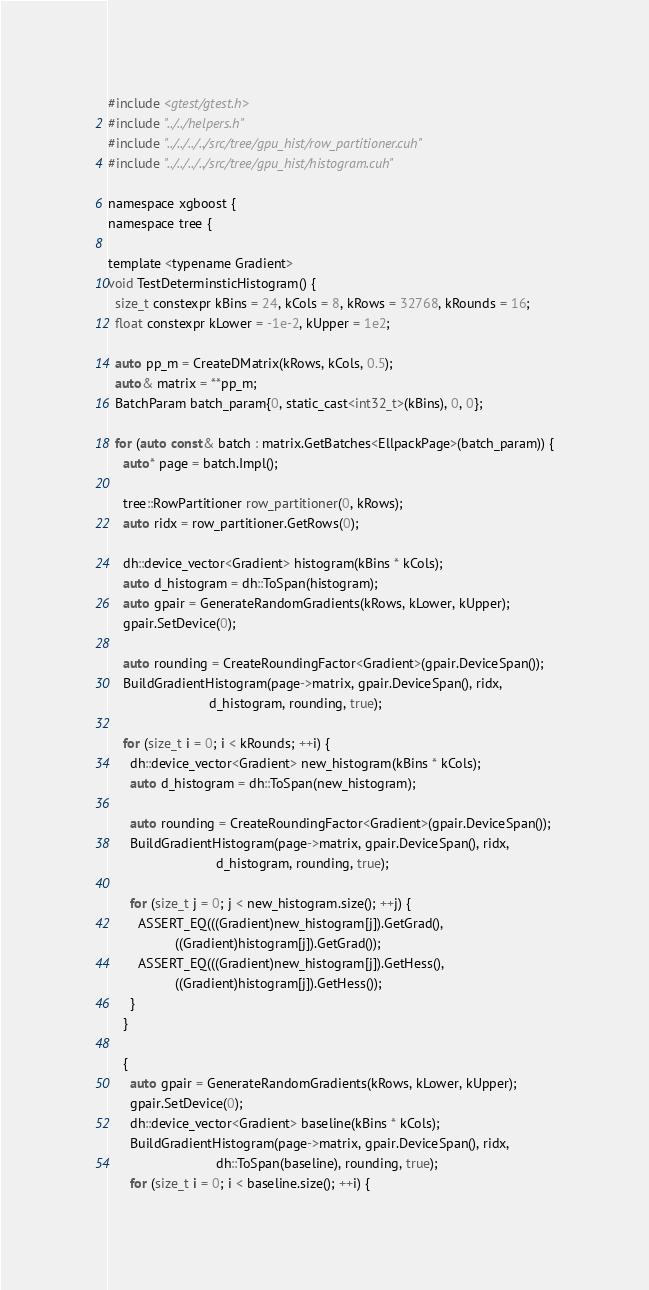Convert code to text. <code><loc_0><loc_0><loc_500><loc_500><_Cuda_>#include <gtest/gtest.h>
#include "../../helpers.h"
#include "../../../../src/tree/gpu_hist/row_partitioner.cuh"
#include "../../../../src/tree/gpu_hist/histogram.cuh"

namespace xgboost {
namespace tree {

template <typename Gradient>
void TestDeterminsticHistogram() {
  size_t constexpr kBins = 24, kCols = 8, kRows = 32768, kRounds = 16;
  float constexpr kLower = -1e-2, kUpper = 1e2;

  auto pp_m = CreateDMatrix(kRows, kCols, 0.5);
  auto& matrix = **pp_m;
  BatchParam batch_param{0, static_cast<int32_t>(kBins), 0, 0};

  for (auto const& batch : matrix.GetBatches<EllpackPage>(batch_param)) {
    auto* page = batch.Impl();

    tree::RowPartitioner row_partitioner(0, kRows);
    auto ridx = row_partitioner.GetRows(0);

    dh::device_vector<Gradient> histogram(kBins * kCols);
    auto d_histogram = dh::ToSpan(histogram);
    auto gpair = GenerateRandomGradients(kRows, kLower, kUpper);
    gpair.SetDevice(0);

    auto rounding = CreateRoundingFactor<Gradient>(gpair.DeviceSpan());
    BuildGradientHistogram(page->matrix, gpair.DeviceSpan(), ridx,
                           d_histogram, rounding, true);

    for (size_t i = 0; i < kRounds; ++i) {
      dh::device_vector<Gradient> new_histogram(kBins * kCols);
      auto d_histogram = dh::ToSpan(new_histogram);

      auto rounding = CreateRoundingFactor<Gradient>(gpair.DeviceSpan());
      BuildGradientHistogram(page->matrix, gpair.DeviceSpan(), ridx,
                             d_histogram, rounding, true);

      for (size_t j = 0; j < new_histogram.size(); ++j) {
        ASSERT_EQ(((Gradient)new_histogram[j]).GetGrad(),
                  ((Gradient)histogram[j]).GetGrad());
        ASSERT_EQ(((Gradient)new_histogram[j]).GetHess(),
                  ((Gradient)histogram[j]).GetHess());
      }
    }

    {
      auto gpair = GenerateRandomGradients(kRows, kLower, kUpper);
      gpair.SetDevice(0);
      dh::device_vector<Gradient> baseline(kBins * kCols);
      BuildGradientHistogram(page->matrix, gpair.DeviceSpan(), ridx,
                             dh::ToSpan(baseline), rounding, true);
      for (size_t i = 0; i < baseline.size(); ++i) {</code> 